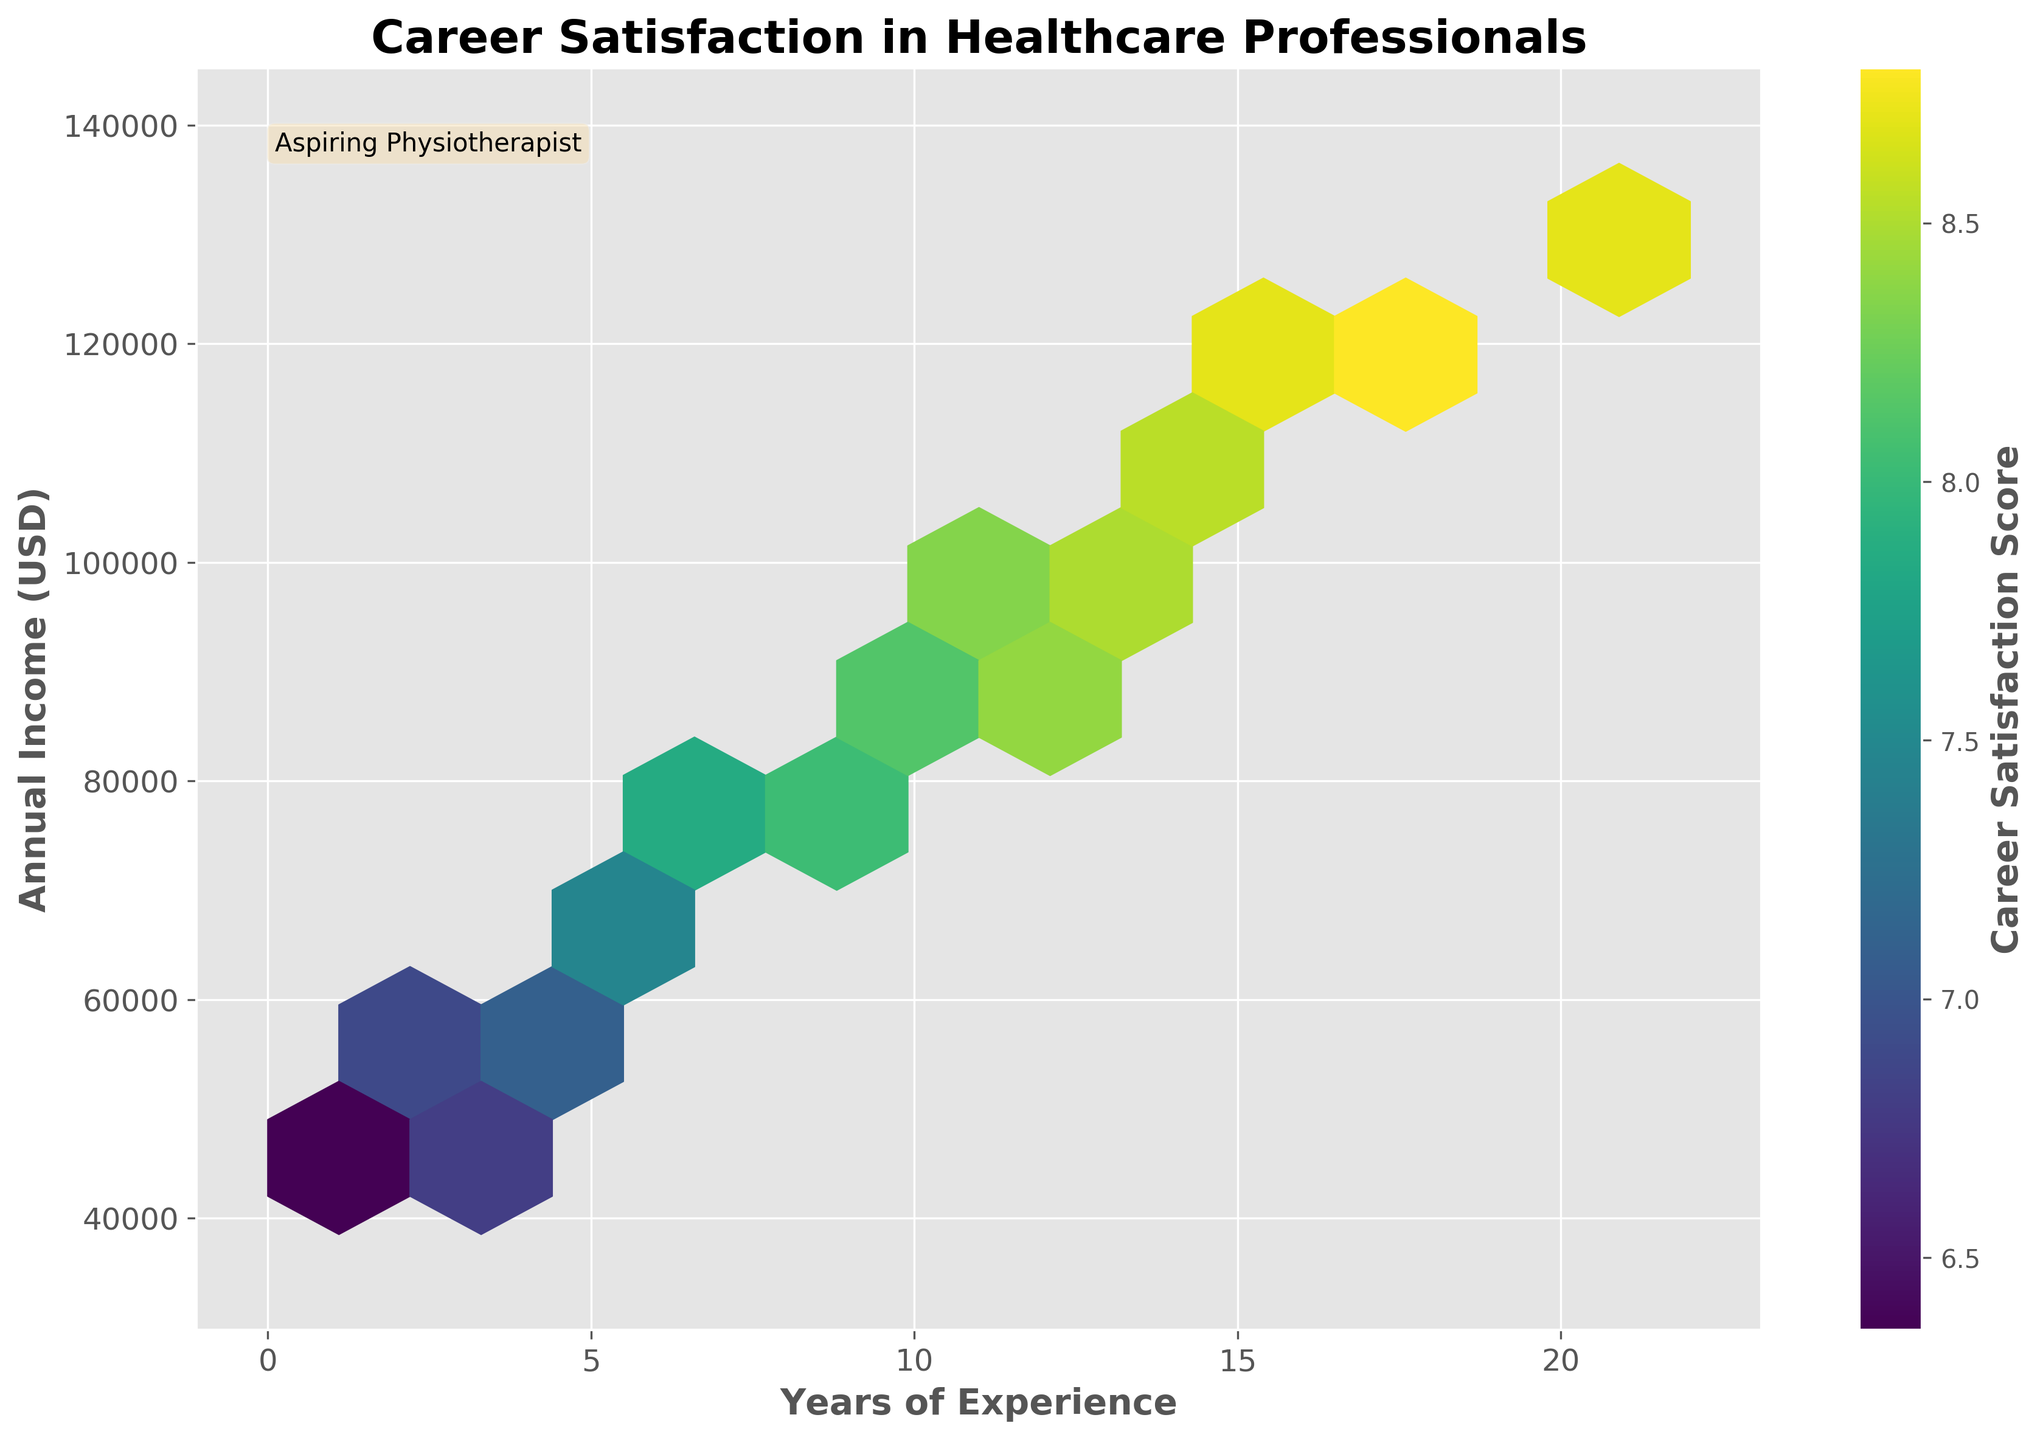What is the title of the plot? The title of the plot is the text located at the top center of the figure, which provides a brief description of the data being visualized.
Answer: Career Satisfaction in Healthcare Professionals What do the colors in the hexbin plot represent? The color intensity in the hexbin plot represents the average career satisfaction score, as indicated by the color bar to the right of the plot. The darker shades correspond to higher satisfaction scores, and the lighter shades correspond to lower satisfaction scores.
Answer: Career Satisfaction Score How many bins appear to have the highest career satisfaction scores? By observing the color intensity, bins with the highest career satisfaction scores will be the darkest shade. Count the number of these darkest bins.
Answer: 1-2 In which range of years of experience and annual income is the highest career satisfaction observed? Look for the bin with the darkest shade and note its corresponding values on the x-axis (Years of Experience) and the y-axis (Annual Income).
Answer: Approximately 16-20 years of experience and $110,000-$120,000 annual income What is the typical career satisfaction score for professionals with less than 5 years of experience? Focus on the lower end of the x-axis (0-5 years of experience) and check the average color intensity in this region, as indicated by the color bar.
Answer: Around 6-7 How does the career satisfaction score vary with annual income for professionals with 10 years of experience? Identify data points corresponding to 10 years of experience on the x-axis and observe the variation in color intensity along the y-axis (Annual Income) for these points.
Answer: Satisfaction increases with income, ranging from 8.0 to 8.2 Which range has a more significant enhancement in career satisfaction with increasing years of experience, $50,000-$70,000 or $90,000-$110,000? Compare the change in color intensity along the x-axis (Years of Experience) within the specified income ranges on the y-axis.
Answer: $90,000-$110,000 Is there a noticeable trend in career satisfaction with increasing years of experience and income? Examine the color gradient from left to right and bottom to top of the plot, which corresponds to increasing years of experience and annual income, respectively.
Answer: Yes, satisfaction generally increases What is the median career satisfaction score for professionals earning between $70,000 and $90,000 annually? Focus on the bins within the $70,000-$90,000 income range on the y-axis and determine the median color intensity as indicated by the color bar.
Answer: About 7.9-8.0 Which axis shows the years of experience in the plot? The axis labels provide this information, and the x-axis is labeled 'Years of Experience'.
Answer: x-axis 